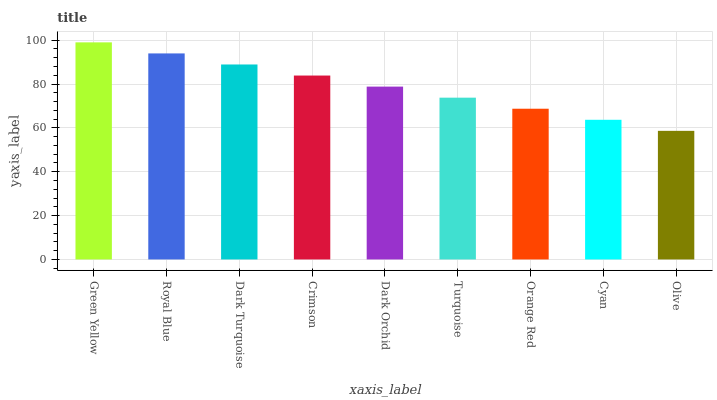Is Olive the minimum?
Answer yes or no. Yes. Is Green Yellow the maximum?
Answer yes or no. Yes. Is Royal Blue the minimum?
Answer yes or no. No. Is Royal Blue the maximum?
Answer yes or no. No. Is Green Yellow greater than Royal Blue?
Answer yes or no. Yes. Is Royal Blue less than Green Yellow?
Answer yes or no. Yes. Is Royal Blue greater than Green Yellow?
Answer yes or no. No. Is Green Yellow less than Royal Blue?
Answer yes or no. No. Is Dark Orchid the high median?
Answer yes or no. Yes. Is Dark Orchid the low median?
Answer yes or no. Yes. Is Orange Red the high median?
Answer yes or no. No. Is Turquoise the low median?
Answer yes or no. No. 